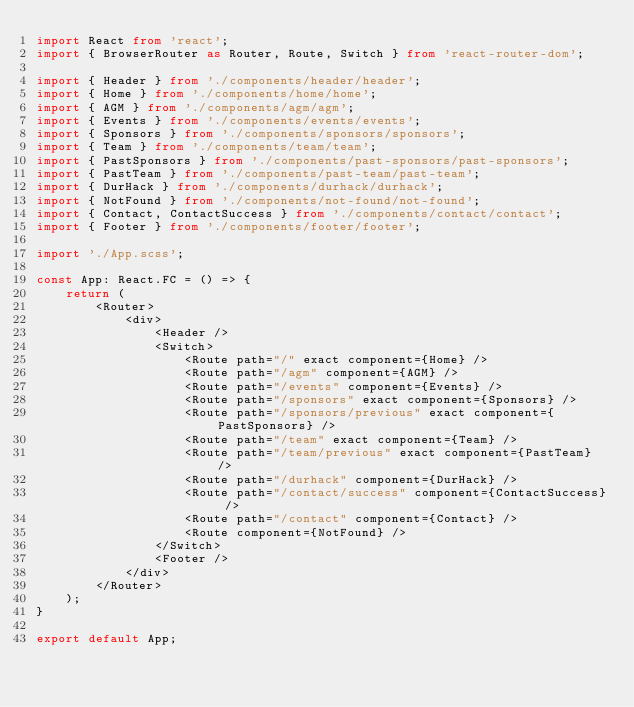Convert code to text. <code><loc_0><loc_0><loc_500><loc_500><_TypeScript_>import React from 'react';
import { BrowserRouter as Router, Route, Switch } from 'react-router-dom';

import { Header } from './components/header/header';
import { Home } from './components/home/home';
import { AGM } from './components/agm/agm';
import { Events } from './components/events/events';
import { Sponsors } from './components/sponsors/sponsors';
import { Team } from './components/team/team';
import { PastSponsors } from './components/past-sponsors/past-sponsors';
import { PastTeam } from './components/past-team/past-team';
import { DurHack } from './components/durhack/durhack';
import { NotFound } from './components/not-found/not-found';
import { Contact, ContactSuccess } from './components/contact/contact';
import { Footer } from './components/footer/footer';

import './App.scss';

const App: React.FC = () => {
	return (
		<Router>
			<div>
				<Header />
				<Switch>
					<Route path="/" exact component={Home} />
					<Route path="/agm" component={AGM} />
					<Route path="/events" component={Events} />
					<Route path="/sponsors" exact component={Sponsors} />
					<Route path="/sponsors/previous" exact component={PastSponsors} />
					<Route path="/team" exact component={Team} />
					<Route path="/team/previous" exact component={PastTeam} />
					<Route path="/durhack" component={DurHack} />
					<Route path="/contact/success" component={ContactSuccess} />
					<Route path="/contact" component={Contact} />
					<Route component={NotFound} />
				</Switch>
				<Footer />
			</div>
		</Router>
	);
}

export default App;
</code> 